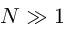Convert formula to latex. <formula><loc_0><loc_0><loc_500><loc_500>N \gg 1</formula> 